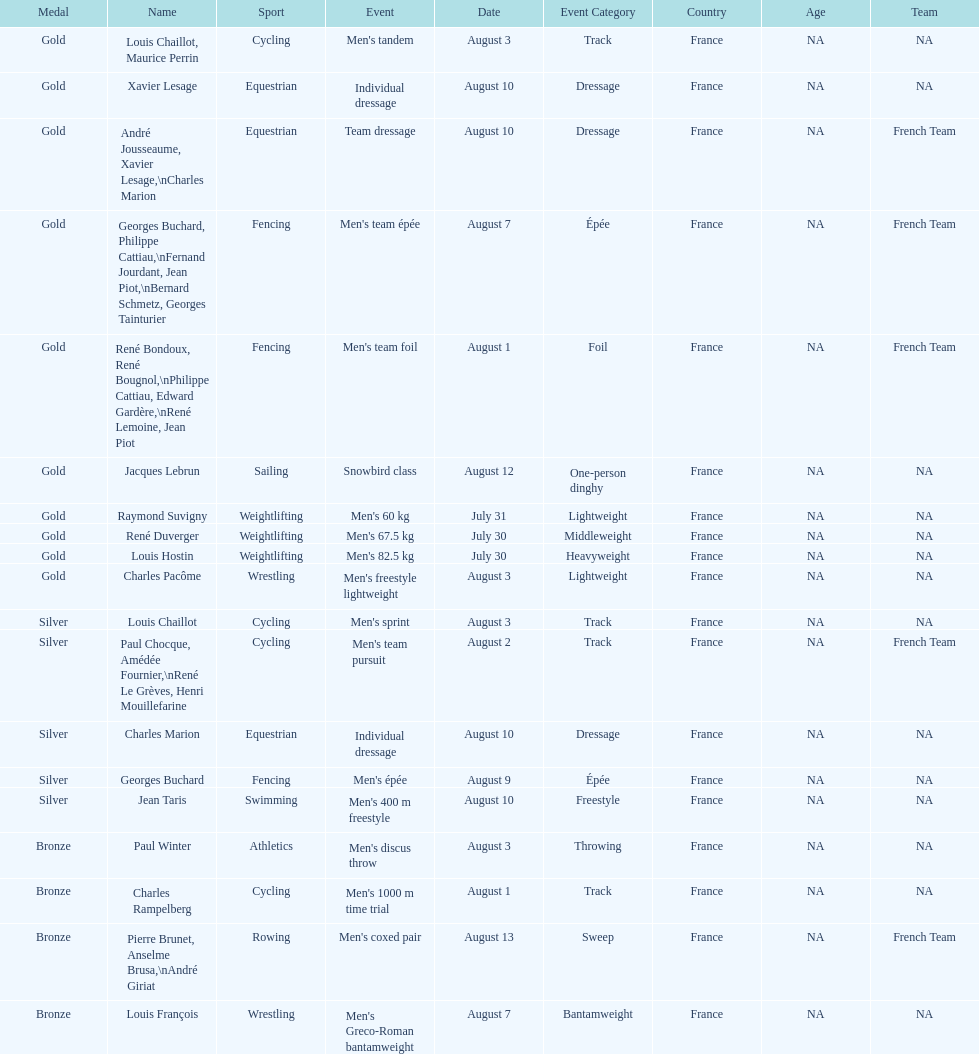What sport did louis challiot win the same medal as paul chocque in? Cycling. 